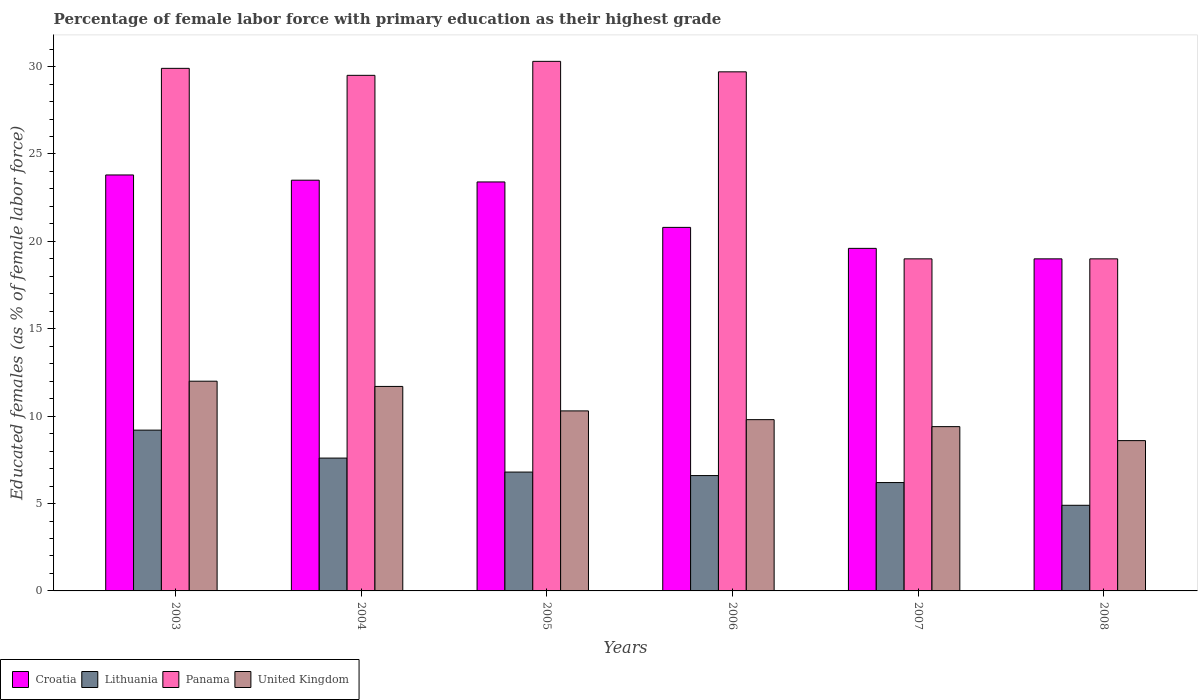How many different coloured bars are there?
Your answer should be very brief. 4. What is the label of the 5th group of bars from the left?
Your answer should be compact. 2007. What is the percentage of female labor force with primary education in United Kingdom in 2003?
Your answer should be compact. 12. Across all years, what is the maximum percentage of female labor force with primary education in Croatia?
Your answer should be compact. 23.8. Across all years, what is the minimum percentage of female labor force with primary education in Lithuania?
Provide a short and direct response. 4.9. In which year was the percentage of female labor force with primary education in Panama maximum?
Offer a terse response. 2005. In which year was the percentage of female labor force with primary education in Lithuania minimum?
Provide a succinct answer. 2008. What is the total percentage of female labor force with primary education in United Kingdom in the graph?
Ensure brevity in your answer.  61.8. What is the difference between the percentage of female labor force with primary education in Panama in 2003 and that in 2007?
Your answer should be very brief. 10.9. What is the difference between the percentage of female labor force with primary education in United Kingdom in 2007 and the percentage of female labor force with primary education in Croatia in 2004?
Keep it short and to the point. -14.1. What is the average percentage of female labor force with primary education in Lithuania per year?
Keep it short and to the point. 6.88. In the year 2007, what is the difference between the percentage of female labor force with primary education in United Kingdom and percentage of female labor force with primary education in Lithuania?
Your answer should be very brief. 3.2. In how many years, is the percentage of female labor force with primary education in Lithuania greater than 19 %?
Give a very brief answer. 0. What is the ratio of the percentage of female labor force with primary education in Lithuania in 2005 to that in 2007?
Provide a succinct answer. 1.1. What is the difference between the highest and the second highest percentage of female labor force with primary education in United Kingdom?
Your answer should be very brief. 0.3. What is the difference between the highest and the lowest percentage of female labor force with primary education in Croatia?
Give a very brief answer. 4.8. In how many years, is the percentage of female labor force with primary education in Croatia greater than the average percentage of female labor force with primary education in Croatia taken over all years?
Make the answer very short. 3. What does the 1st bar from the left in 2004 represents?
Provide a succinct answer. Croatia. Is it the case that in every year, the sum of the percentage of female labor force with primary education in Panama and percentage of female labor force with primary education in Lithuania is greater than the percentage of female labor force with primary education in Croatia?
Offer a very short reply. Yes. What is the difference between two consecutive major ticks on the Y-axis?
Your answer should be compact. 5. Does the graph contain grids?
Your answer should be very brief. No. How many legend labels are there?
Ensure brevity in your answer.  4. What is the title of the graph?
Provide a short and direct response. Percentage of female labor force with primary education as their highest grade. Does "Estonia" appear as one of the legend labels in the graph?
Make the answer very short. No. What is the label or title of the X-axis?
Your answer should be compact. Years. What is the label or title of the Y-axis?
Provide a succinct answer. Educated females (as % of female labor force). What is the Educated females (as % of female labor force) in Croatia in 2003?
Your answer should be very brief. 23.8. What is the Educated females (as % of female labor force) of Lithuania in 2003?
Provide a short and direct response. 9.2. What is the Educated females (as % of female labor force) of Panama in 2003?
Provide a short and direct response. 29.9. What is the Educated females (as % of female labor force) of United Kingdom in 2003?
Provide a short and direct response. 12. What is the Educated females (as % of female labor force) in Lithuania in 2004?
Make the answer very short. 7.6. What is the Educated females (as % of female labor force) in Panama in 2004?
Provide a short and direct response. 29.5. What is the Educated females (as % of female labor force) in United Kingdom in 2004?
Your answer should be very brief. 11.7. What is the Educated females (as % of female labor force) in Croatia in 2005?
Your answer should be very brief. 23.4. What is the Educated females (as % of female labor force) of Lithuania in 2005?
Your answer should be compact. 6.8. What is the Educated females (as % of female labor force) of Panama in 2005?
Keep it short and to the point. 30.3. What is the Educated females (as % of female labor force) of United Kingdom in 2005?
Your response must be concise. 10.3. What is the Educated females (as % of female labor force) in Croatia in 2006?
Provide a succinct answer. 20.8. What is the Educated females (as % of female labor force) in Lithuania in 2006?
Provide a short and direct response. 6.6. What is the Educated females (as % of female labor force) in Panama in 2006?
Make the answer very short. 29.7. What is the Educated females (as % of female labor force) of United Kingdom in 2006?
Keep it short and to the point. 9.8. What is the Educated females (as % of female labor force) of Croatia in 2007?
Make the answer very short. 19.6. What is the Educated females (as % of female labor force) in Lithuania in 2007?
Provide a short and direct response. 6.2. What is the Educated females (as % of female labor force) of United Kingdom in 2007?
Provide a short and direct response. 9.4. What is the Educated females (as % of female labor force) in Lithuania in 2008?
Offer a very short reply. 4.9. What is the Educated females (as % of female labor force) of United Kingdom in 2008?
Ensure brevity in your answer.  8.6. Across all years, what is the maximum Educated females (as % of female labor force) of Croatia?
Keep it short and to the point. 23.8. Across all years, what is the maximum Educated females (as % of female labor force) of Lithuania?
Provide a succinct answer. 9.2. Across all years, what is the maximum Educated females (as % of female labor force) of Panama?
Provide a short and direct response. 30.3. Across all years, what is the maximum Educated females (as % of female labor force) in United Kingdom?
Your answer should be very brief. 12. Across all years, what is the minimum Educated females (as % of female labor force) in Lithuania?
Offer a very short reply. 4.9. Across all years, what is the minimum Educated females (as % of female labor force) of United Kingdom?
Your answer should be very brief. 8.6. What is the total Educated females (as % of female labor force) of Croatia in the graph?
Offer a very short reply. 130.1. What is the total Educated females (as % of female labor force) in Lithuania in the graph?
Your response must be concise. 41.3. What is the total Educated females (as % of female labor force) of Panama in the graph?
Your answer should be very brief. 157.4. What is the total Educated females (as % of female labor force) of United Kingdom in the graph?
Ensure brevity in your answer.  61.8. What is the difference between the Educated females (as % of female labor force) in Croatia in 2003 and that in 2004?
Give a very brief answer. 0.3. What is the difference between the Educated females (as % of female labor force) in Lithuania in 2003 and that in 2004?
Provide a succinct answer. 1.6. What is the difference between the Educated females (as % of female labor force) of Panama in 2003 and that in 2004?
Keep it short and to the point. 0.4. What is the difference between the Educated females (as % of female labor force) of United Kingdom in 2003 and that in 2004?
Offer a very short reply. 0.3. What is the difference between the Educated females (as % of female labor force) in Croatia in 2003 and that in 2007?
Provide a short and direct response. 4.2. What is the difference between the Educated females (as % of female labor force) in United Kingdom in 2003 and that in 2007?
Offer a very short reply. 2.6. What is the difference between the Educated females (as % of female labor force) in Croatia in 2003 and that in 2008?
Keep it short and to the point. 4.8. What is the difference between the Educated females (as % of female labor force) in Panama in 2004 and that in 2005?
Keep it short and to the point. -0.8. What is the difference between the Educated females (as % of female labor force) in United Kingdom in 2004 and that in 2005?
Offer a very short reply. 1.4. What is the difference between the Educated females (as % of female labor force) of Croatia in 2004 and that in 2006?
Provide a short and direct response. 2.7. What is the difference between the Educated females (as % of female labor force) of Panama in 2004 and that in 2006?
Make the answer very short. -0.2. What is the difference between the Educated females (as % of female labor force) of United Kingdom in 2004 and that in 2006?
Your response must be concise. 1.9. What is the difference between the Educated females (as % of female labor force) in Croatia in 2004 and that in 2007?
Give a very brief answer. 3.9. What is the difference between the Educated females (as % of female labor force) of Panama in 2004 and that in 2007?
Your response must be concise. 10.5. What is the difference between the Educated females (as % of female labor force) in Croatia in 2005 and that in 2006?
Provide a succinct answer. 2.6. What is the difference between the Educated females (as % of female labor force) in Lithuania in 2005 and that in 2006?
Offer a very short reply. 0.2. What is the difference between the Educated females (as % of female labor force) of Panama in 2005 and that in 2006?
Your response must be concise. 0.6. What is the difference between the Educated females (as % of female labor force) in United Kingdom in 2005 and that in 2006?
Provide a short and direct response. 0.5. What is the difference between the Educated females (as % of female labor force) in Panama in 2005 and that in 2007?
Your answer should be very brief. 11.3. What is the difference between the Educated females (as % of female labor force) of Lithuania in 2005 and that in 2008?
Offer a very short reply. 1.9. What is the difference between the Educated females (as % of female labor force) of Panama in 2005 and that in 2008?
Keep it short and to the point. 11.3. What is the difference between the Educated females (as % of female labor force) of United Kingdom in 2005 and that in 2008?
Your response must be concise. 1.7. What is the difference between the Educated females (as % of female labor force) of Croatia in 2006 and that in 2007?
Make the answer very short. 1.2. What is the difference between the Educated females (as % of female labor force) of Lithuania in 2006 and that in 2007?
Your response must be concise. 0.4. What is the difference between the Educated females (as % of female labor force) in Panama in 2006 and that in 2007?
Keep it short and to the point. 10.7. What is the difference between the Educated females (as % of female labor force) in Panama in 2006 and that in 2008?
Offer a very short reply. 10.7. What is the difference between the Educated females (as % of female labor force) of United Kingdom in 2006 and that in 2008?
Your answer should be compact. 1.2. What is the difference between the Educated females (as % of female labor force) in Croatia in 2007 and that in 2008?
Keep it short and to the point. 0.6. What is the difference between the Educated females (as % of female labor force) in Panama in 2007 and that in 2008?
Offer a terse response. 0. What is the difference between the Educated females (as % of female labor force) in United Kingdom in 2007 and that in 2008?
Provide a short and direct response. 0.8. What is the difference between the Educated females (as % of female labor force) in Croatia in 2003 and the Educated females (as % of female labor force) in Panama in 2004?
Your answer should be very brief. -5.7. What is the difference between the Educated females (as % of female labor force) of Lithuania in 2003 and the Educated females (as % of female labor force) of Panama in 2004?
Offer a terse response. -20.3. What is the difference between the Educated females (as % of female labor force) of Croatia in 2003 and the Educated females (as % of female labor force) of Lithuania in 2005?
Ensure brevity in your answer.  17. What is the difference between the Educated females (as % of female labor force) in Croatia in 2003 and the Educated females (as % of female labor force) in Panama in 2005?
Your answer should be very brief. -6.5. What is the difference between the Educated females (as % of female labor force) of Croatia in 2003 and the Educated females (as % of female labor force) of United Kingdom in 2005?
Provide a short and direct response. 13.5. What is the difference between the Educated females (as % of female labor force) in Lithuania in 2003 and the Educated females (as % of female labor force) in Panama in 2005?
Offer a very short reply. -21.1. What is the difference between the Educated females (as % of female labor force) of Lithuania in 2003 and the Educated females (as % of female labor force) of United Kingdom in 2005?
Your answer should be compact. -1.1. What is the difference between the Educated females (as % of female labor force) of Panama in 2003 and the Educated females (as % of female labor force) of United Kingdom in 2005?
Provide a succinct answer. 19.6. What is the difference between the Educated females (as % of female labor force) in Croatia in 2003 and the Educated females (as % of female labor force) in Lithuania in 2006?
Provide a short and direct response. 17.2. What is the difference between the Educated females (as % of female labor force) of Croatia in 2003 and the Educated females (as % of female labor force) of United Kingdom in 2006?
Your response must be concise. 14. What is the difference between the Educated females (as % of female labor force) in Lithuania in 2003 and the Educated females (as % of female labor force) in Panama in 2006?
Keep it short and to the point. -20.5. What is the difference between the Educated females (as % of female labor force) of Lithuania in 2003 and the Educated females (as % of female labor force) of United Kingdom in 2006?
Offer a very short reply. -0.6. What is the difference between the Educated females (as % of female labor force) of Panama in 2003 and the Educated females (as % of female labor force) of United Kingdom in 2006?
Offer a very short reply. 20.1. What is the difference between the Educated females (as % of female labor force) of Croatia in 2003 and the Educated females (as % of female labor force) of Lithuania in 2007?
Give a very brief answer. 17.6. What is the difference between the Educated females (as % of female labor force) of Croatia in 2003 and the Educated females (as % of female labor force) of Panama in 2007?
Offer a very short reply. 4.8. What is the difference between the Educated females (as % of female labor force) of Croatia in 2003 and the Educated females (as % of female labor force) of United Kingdom in 2007?
Offer a very short reply. 14.4. What is the difference between the Educated females (as % of female labor force) of Lithuania in 2003 and the Educated females (as % of female labor force) of United Kingdom in 2007?
Offer a terse response. -0.2. What is the difference between the Educated females (as % of female labor force) in Panama in 2003 and the Educated females (as % of female labor force) in United Kingdom in 2007?
Your response must be concise. 20.5. What is the difference between the Educated females (as % of female labor force) of Croatia in 2003 and the Educated females (as % of female labor force) of United Kingdom in 2008?
Offer a very short reply. 15.2. What is the difference between the Educated females (as % of female labor force) of Lithuania in 2003 and the Educated females (as % of female labor force) of United Kingdom in 2008?
Keep it short and to the point. 0.6. What is the difference between the Educated females (as % of female labor force) in Panama in 2003 and the Educated females (as % of female labor force) in United Kingdom in 2008?
Your response must be concise. 21.3. What is the difference between the Educated females (as % of female labor force) in Croatia in 2004 and the Educated females (as % of female labor force) in Lithuania in 2005?
Your response must be concise. 16.7. What is the difference between the Educated females (as % of female labor force) of Croatia in 2004 and the Educated females (as % of female labor force) of Panama in 2005?
Make the answer very short. -6.8. What is the difference between the Educated females (as % of female labor force) in Lithuania in 2004 and the Educated females (as % of female labor force) in Panama in 2005?
Offer a very short reply. -22.7. What is the difference between the Educated females (as % of female labor force) in Croatia in 2004 and the Educated females (as % of female labor force) in Lithuania in 2006?
Give a very brief answer. 16.9. What is the difference between the Educated females (as % of female labor force) of Croatia in 2004 and the Educated females (as % of female labor force) of Panama in 2006?
Your answer should be very brief. -6.2. What is the difference between the Educated females (as % of female labor force) of Lithuania in 2004 and the Educated females (as % of female labor force) of Panama in 2006?
Your answer should be very brief. -22.1. What is the difference between the Educated females (as % of female labor force) of Lithuania in 2004 and the Educated females (as % of female labor force) of United Kingdom in 2006?
Give a very brief answer. -2.2. What is the difference between the Educated females (as % of female labor force) of Panama in 2004 and the Educated females (as % of female labor force) of United Kingdom in 2006?
Keep it short and to the point. 19.7. What is the difference between the Educated females (as % of female labor force) of Croatia in 2004 and the Educated females (as % of female labor force) of Lithuania in 2007?
Provide a short and direct response. 17.3. What is the difference between the Educated females (as % of female labor force) of Croatia in 2004 and the Educated females (as % of female labor force) of United Kingdom in 2007?
Offer a very short reply. 14.1. What is the difference between the Educated females (as % of female labor force) in Lithuania in 2004 and the Educated females (as % of female labor force) in Panama in 2007?
Offer a very short reply. -11.4. What is the difference between the Educated females (as % of female labor force) of Lithuania in 2004 and the Educated females (as % of female labor force) of United Kingdom in 2007?
Make the answer very short. -1.8. What is the difference between the Educated females (as % of female labor force) in Panama in 2004 and the Educated females (as % of female labor force) in United Kingdom in 2007?
Offer a very short reply. 20.1. What is the difference between the Educated females (as % of female labor force) in Croatia in 2004 and the Educated females (as % of female labor force) in Lithuania in 2008?
Provide a short and direct response. 18.6. What is the difference between the Educated females (as % of female labor force) of Croatia in 2004 and the Educated females (as % of female labor force) of Panama in 2008?
Your answer should be compact. 4.5. What is the difference between the Educated females (as % of female labor force) of Lithuania in 2004 and the Educated females (as % of female labor force) of Panama in 2008?
Offer a terse response. -11.4. What is the difference between the Educated females (as % of female labor force) in Panama in 2004 and the Educated females (as % of female labor force) in United Kingdom in 2008?
Provide a short and direct response. 20.9. What is the difference between the Educated females (as % of female labor force) of Croatia in 2005 and the Educated females (as % of female labor force) of Lithuania in 2006?
Offer a very short reply. 16.8. What is the difference between the Educated females (as % of female labor force) in Croatia in 2005 and the Educated females (as % of female labor force) in United Kingdom in 2006?
Provide a short and direct response. 13.6. What is the difference between the Educated females (as % of female labor force) of Lithuania in 2005 and the Educated females (as % of female labor force) of Panama in 2006?
Provide a short and direct response. -22.9. What is the difference between the Educated females (as % of female labor force) of Lithuania in 2005 and the Educated females (as % of female labor force) of United Kingdom in 2006?
Give a very brief answer. -3. What is the difference between the Educated females (as % of female labor force) in Panama in 2005 and the Educated females (as % of female labor force) in United Kingdom in 2006?
Give a very brief answer. 20.5. What is the difference between the Educated females (as % of female labor force) in Lithuania in 2005 and the Educated females (as % of female labor force) in Panama in 2007?
Make the answer very short. -12.2. What is the difference between the Educated females (as % of female labor force) in Panama in 2005 and the Educated females (as % of female labor force) in United Kingdom in 2007?
Your response must be concise. 20.9. What is the difference between the Educated females (as % of female labor force) of Croatia in 2005 and the Educated females (as % of female labor force) of Panama in 2008?
Make the answer very short. 4.4. What is the difference between the Educated females (as % of female labor force) of Lithuania in 2005 and the Educated females (as % of female labor force) of United Kingdom in 2008?
Ensure brevity in your answer.  -1.8. What is the difference between the Educated females (as % of female labor force) in Panama in 2005 and the Educated females (as % of female labor force) in United Kingdom in 2008?
Provide a short and direct response. 21.7. What is the difference between the Educated females (as % of female labor force) of Croatia in 2006 and the Educated females (as % of female labor force) of Lithuania in 2007?
Provide a short and direct response. 14.6. What is the difference between the Educated females (as % of female labor force) in Croatia in 2006 and the Educated females (as % of female labor force) in Panama in 2007?
Your answer should be very brief. 1.8. What is the difference between the Educated females (as % of female labor force) of Lithuania in 2006 and the Educated females (as % of female labor force) of Panama in 2007?
Offer a very short reply. -12.4. What is the difference between the Educated females (as % of female labor force) of Panama in 2006 and the Educated females (as % of female labor force) of United Kingdom in 2007?
Ensure brevity in your answer.  20.3. What is the difference between the Educated females (as % of female labor force) of Lithuania in 2006 and the Educated females (as % of female labor force) of Panama in 2008?
Ensure brevity in your answer.  -12.4. What is the difference between the Educated females (as % of female labor force) of Panama in 2006 and the Educated females (as % of female labor force) of United Kingdom in 2008?
Your answer should be compact. 21.1. What is the difference between the Educated females (as % of female labor force) of Croatia in 2007 and the Educated females (as % of female labor force) of United Kingdom in 2008?
Provide a short and direct response. 11. What is the difference between the Educated females (as % of female labor force) of Lithuania in 2007 and the Educated females (as % of female labor force) of United Kingdom in 2008?
Give a very brief answer. -2.4. What is the average Educated females (as % of female labor force) of Croatia per year?
Provide a short and direct response. 21.68. What is the average Educated females (as % of female labor force) of Lithuania per year?
Your answer should be compact. 6.88. What is the average Educated females (as % of female labor force) of Panama per year?
Ensure brevity in your answer.  26.23. What is the average Educated females (as % of female labor force) of United Kingdom per year?
Your response must be concise. 10.3. In the year 2003, what is the difference between the Educated females (as % of female labor force) of Croatia and Educated females (as % of female labor force) of Lithuania?
Your answer should be compact. 14.6. In the year 2003, what is the difference between the Educated females (as % of female labor force) of Lithuania and Educated females (as % of female labor force) of Panama?
Your answer should be very brief. -20.7. In the year 2003, what is the difference between the Educated females (as % of female labor force) of Lithuania and Educated females (as % of female labor force) of United Kingdom?
Offer a very short reply. -2.8. In the year 2003, what is the difference between the Educated females (as % of female labor force) in Panama and Educated females (as % of female labor force) in United Kingdom?
Offer a very short reply. 17.9. In the year 2004, what is the difference between the Educated females (as % of female labor force) of Croatia and Educated females (as % of female labor force) of United Kingdom?
Offer a terse response. 11.8. In the year 2004, what is the difference between the Educated females (as % of female labor force) of Lithuania and Educated females (as % of female labor force) of Panama?
Keep it short and to the point. -21.9. In the year 2004, what is the difference between the Educated females (as % of female labor force) in Panama and Educated females (as % of female labor force) in United Kingdom?
Provide a succinct answer. 17.8. In the year 2005, what is the difference between the Educated females (as % of female labor force) in Croatia and Educated females (as % of female labor force) in Lithuania?
Your response must be concise. 16.6. In the year 2005, what is the difference between the Educated females (as % of female labor force) in Lithuania and Educated females (as % of female labor force) in Panama?
Make the answer very short. -23.5. In the year 2006, what is the difference between the Educated females (as % of female labor force) in Croatia and Educated females (as % of female labor force) in Lithuania?
Keep it short and to the point. 14.2. In the year 2006, what is the difference between the Educated females (as % of female labor force) of Croatia and Educated females (as % of female labor force) of United Kingdom?
Your answer should be compact. 11. In the year 2006, what is the difference between the Educated females (as % of female labor force) in Lithuania and Educated females (as % of female labor force) in Panama?
Your answer should be very brief. -23.1. In the year 2006, what is the difference between the Educated females (as % of female labor force) in Panama and Educated females (as % of female labor force) in United Kingdom?
Your response must be concise. 19.9. In the year 2007, what is the difference between the Educated females (as % of female labor force) in Croatia and Educated females (as % of female labor force) in Lithuania?
Your answer should be very brief. 13.4. In the year 2007, what is the difference between the Educated females (as % of female labor force) of Lithuania and Educated females (as % of female labor force) of United Kingdom?
Make the answer very short. -3.2. In the year 2007, what is the difference between the Educated females (as % of female labor force) in Panama and Educated females (as % of female labor force) in United Kingdom?
Your answer should be compact. 9.6. In the year 2008, what is the difference between the Educated females (as % of female labor force) of Lithuania and Educated females (as % of female labor force) of Panama?
Your answer should be very brief. -14.1. What is the ratio of the Educated females (as % of female labor force) in Croatia in 2003 to that in 2004?
Offer a terse response. 1.01. What is the ratio of the Educated females (as % of female labor force) of Lithuania in 2003 to that in 2004?
Your response must be concise. 1.21. What is the ratio of the Educated females (as % of female labor force) in Panama in 2003 to that in 2004?
Your answer should be very brief. 1.01. What is the ratio of the Educated females (as % of female labor force) in United Kingdom in 2003 to that in 2004?
Offer a terse response. 1.03. What is the ratio of the Educated females (as % of female labor force) of Croatia in 2003 to that in 2005?
Make the answer very short. 1.02. What is the ratio of the Educated females (as % of female labor force) of Lithuania in 2003 to that in 2005?
Make the answer very short. 1.35. What is the ratio of the Educated females (as % of female labor force) of United Kingdom in 2003 to that in 2005?
Ensure brevity in your answer.  1.17. What is the ratio of the Educated females (as % of female labor force) in Croatia in 2003 to that in 2006?
Offer a terse response. 1.14. What is the ratio of the Educated females (as % of female labor force) in Lithuania in 2003 to that in 2006?
Offer a very short reply. 1.39. What is the ratio of the Educated females (as % of female labor force) of Panama in 2003 to that in 2006?
Provide a short and direct response. 1.01. What is the ratio of the Educated females (as % of female labor force) of United Kingdom in 2003 to that in 2006?
Make the answer very short. 1.22. What is the ratio of the Educated females (as % of female labor force) of Croatia in 2003 to that in 2007?
Ensure brevity in your answer.  1.21. What is the ratio of the Educated females (as % of female labor force) of Lithuania in 2003 to that in 2007?
Ensure brevity in your answer.  1.48. What is the ratio of the Educated females (as % of female labor force) of Panama in 2003 to that in 2007?
Give a very brief answer. 1.57. What is the ratio of the Educated females (as % of female labor force) in United Kingdom in 2003 to that in 2007?
Offer a terse response. 1.28. What is the ratio of the Educated females (as % of female labor force) of Croatia in 2003 to that in 2008?
Your answer should be very brief. 1.25. What is the ratio of the Educated females (as % of female labor force) in Lithuania in 2003 to that in 2008?
Provide a succinct answer. 1.88. What is the ratio of the Educated females (as % of female labor force) of Panama in 2003 to that in 2008?
Your response must be concise. 1.57. What is the ratio of the Educated females (as % of female labor force) of United Kingdom in 2003 to that in 2008?
Keep it short and to the point. 1.4. What is the ratio of the Educated females (as % of female labor force) in Croatia in 2004 to that in 2005?
Offer a very short reply. 1. What is the ratio of the Educated females (as % of female labor force) of Lithuania in 2004 to that in 2005?
Provide a succinct answer. 1.12. What is the ratio of the Educated females (as % of female labor force) in Panama in 2004 to that in 2005?
Give a very brief answer. 0.97. What is the ratio of the Educated females (as % of female labor force) in United Kingdom in 2004 to that in 2005?
Your answer should be compact. 1.14. What is the ratio of the Educated females (as % of female labor force) of Croatia in 2004 to that in 2006?
Give a very brief answer. 1.13. What is the ratio of the Educated females (as % of female labor force) in Lithuania in 2004 to that in 2006?
Give a very brief answer. 1.15. What is the ratio of the Educated females (as % of female labor force) in United Kingdom in 2004 to that in 2006?
Offer a very short reply. 1.19. What is the ratio of the Educated females (as % of female labor force) in Croatia in 2004 to that in 2007?
Your answer should be very brief. 1.2. What is the ratio of the Educated females (as % of female labor force) in Lithuania in 2004 to that in 2007?
Give a very brief answer. 1.23. What is the ratio of the Educated females (as % of female labor force) of Panama in 2004 to that in 2007?
Give a very brief answer. 1.55. What is the ratio of the Educated females (as % of female labor force) of United Kingdom in 2004 to that in 2007?
Your response must be concise. 1.24. What is the ratio of the Educated females (as % of female labor force) of Croatia in 2004 to that in 2008?
Make the answer very short. 1.24. What is the ratio of the Educated females (as % of female labor force) in Lithuania in 2004 to that in 2008?
Provide a succinct answer. 1.55. What is the ratio of the Educated females (as % of female labor force) of Panama in 2004 to that in 2008?
Ensure brevity in your answer.  1.55. What is the ratio of the Educated females (as % of female labor force) of United Kingdom in 2004 to that in 2008?
Give a very brief answer. 1.36. What is the ratio of the Educated females (as % of female labor force) in Lithuania in 2005 to that in 2006?
Offer a terse response. 1.03. What is the ratio of the Educated females (as % of female labor force) of Panama in 2005 to that in 2006?
Provide a short and direct response. 1.02. What is the ratio of the Educated females (as % of female labor force) in United Kingdom in 2005 to that in 2006?
Provide a short and direct response. 1.05. What is the ratio of the Educated females (as % of female labor force) of Croatia in 2005 to that in 2007?
Offer a terse response. 1.19. What is the ratio of the Educated females (as % of female labor force) of Lithuania in 2005 to that in 2007?
Make the answer very short. 1.1. What is the ratio of the Educated females (as % of female labor force) of Panama in 2005 to that in 2007?
Make the answer very short. 1.59. What is the ratio of the Educated females (as % of female labor force) in United Kingdom in 2005 to that in 2007?
Ensure brevity in your answer.  1.1. What is the ratio of the Educated females (as % of female labor force) in Croatia in 2005 to that in 2008?
Make the answer very short. 1.23. What is the ratio of the Educated females (as % of female labor force) of Lithuania in 2005 to that in 2008?
Your response must be concise. 1.39. What is the ratio of the Educated females (as % of female labor force) in Panama in 2005 to that in 2008?
Offer a very short reply. 1.59. What is the ratio of the Educated females (as % of female labor force) in United Kingdom in 2005 to that in 2008?
Give a very brief answer. 1.2. What is the ratio of the Educated females (as % of female labor force) in Croatia in 2006 to that in 2007?
Your answer should be very brief. 1.06. What is the ratio of the Educated females (as % of female labor force) of Lithuania in 2006 to that in 2007?
Your answer should be compact. 1.06. What is the ratio of the Educated females (as % of female labor force) in Panama in 2006 to that in 2007?
Offer a very short reply. 1.56. What is the ratio of the Educated females (as % of female labor force) of United Kingdom in 2006 to that in 2007?
Ensure brevity in your answer.  1.04. What is the ratio of the Educated females (as % of female labor force) of Croatia in 2006 to that in 2008?
Give a very brief answer. 1.09. What is the ratio of the Educated females (as % of female labor force) of Lithuania in 2006 to that in 2008?
Your response must be concise. 1.35. What is the ratio of the Educated females (as % of female labor force) of Panama in 2006 to that in 2008?
Your answer should be compact. 1.56. What is the ratio of the Educated females (as % of female labor force) of United Kingdom in 2006 to that in 2008?
Provide a succinct answer. 1.14. What is the ratio of the Educated females (as % of female labor force) in Croatia in 2007 to that in 2008?
Provide a succinct answer. 1.03. What is the ratio of the Educated females (as % of female labor force) of Lithuania in 2007 to that in 2008?
Your answer should be compact. 1.27. What is the ratio of the Educated females (as % of female labor force) in United Kingdom in 2007 to that in 2008?
Provide a short and direct response. 1.09. What is the difference between the highest and the second highest Educated females (as % of female labor force) in Lithuania?
Your answer should be compact. 1.6. What is the difference between the highest and the lowest Educated females (as % of female labor force) in Croatia?
Make the answer very short. 4.8. What is the difference between the highest and the lowest Educated females (as % of female labor force) of Lithuania?
Give a very brief answer. 4.3. What is the difference between the highest and the lowest Educated females (as % of female labor force) of Panama?
Your answer should be compact. 11.3. 